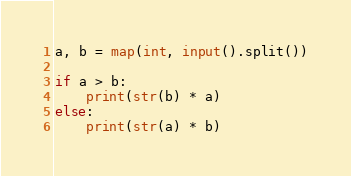<code> <loc_0><loc_0><loc_500><loc_500><_Python_>a, b = map(int, input().split())

if a > b:
    print(str(b) * a)
else:
    print(str(a) * b)
</code> 